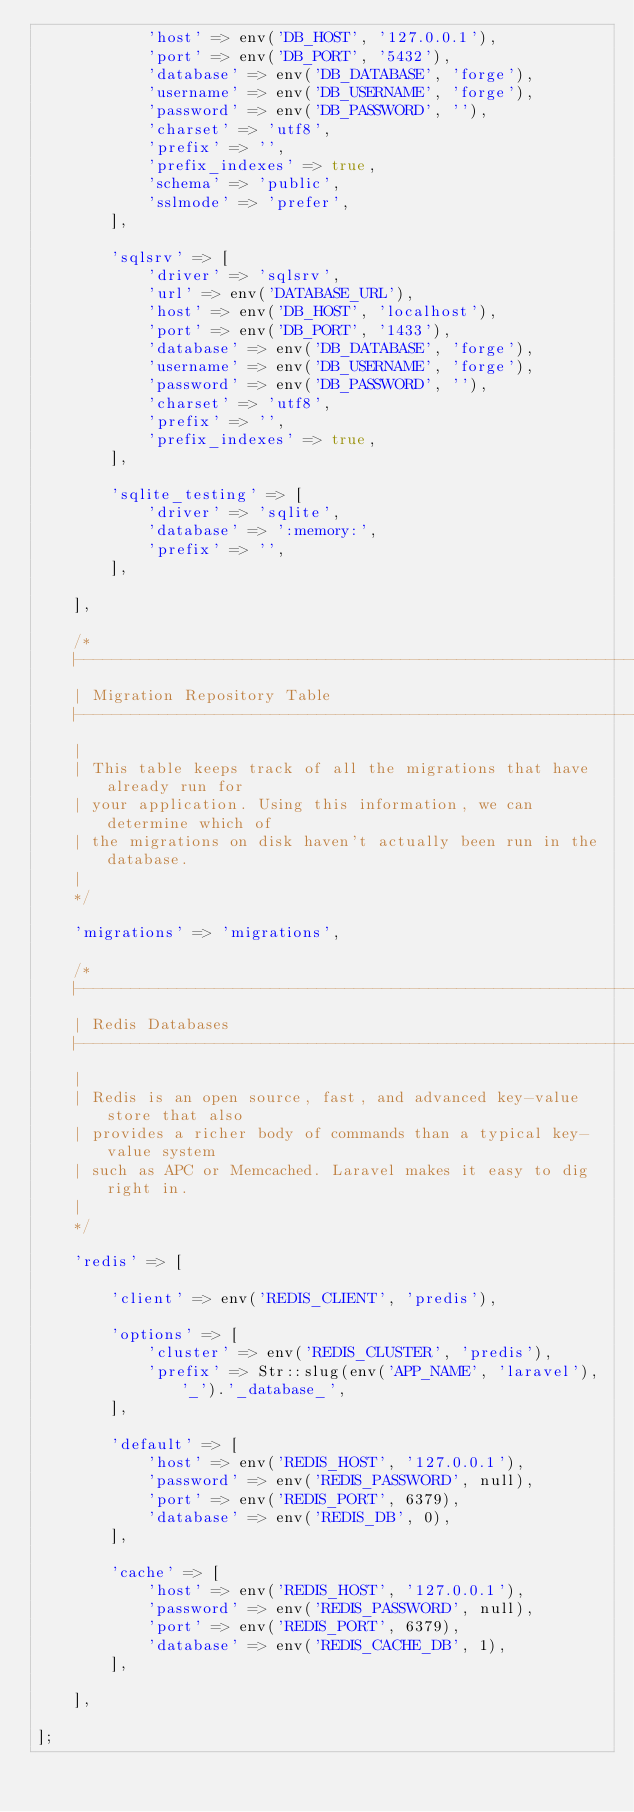Convert code to text. <code><loc_0><loc_0><loc_500><loc_500><_PHP_>            'host' => env('DB_HOST', '127.0.0.1'),
            'port' => env('DB_PORT', '5432'),
            'database' => env('DB_DATABASE', 'forge'),
            'username' => env('DB_USERNAME', 'forge'),
            'password' => env('DB_PASSWORD', ''),
            'charset' => 'utf8',
            'prefix' => '',
            'prefix_indexes' => true,
            'schema' => 'public',
            'sslmode' => 'prefer',
        ],

        'sqlsrv' => [
            'driver' => 'sqlsrv',
            'url' => env('DATABASE_URL'),
            'host' => env('DB_HOST', 'localhost'),
            'port' => env('DB_PORT', '1433'),
            'database' => env('DB_DATABASE', 'forge'),
            'username' => env('DB_USERNAME', 'forge'),
            'password' => env('DB_PASSWORD', ''),
            'charset' => 'utf8',
            'prefix' => '',
            'prefix_indexes' => true,
        ],

        'sqlite_testing' => [
            'driver' => 'sqlite',
            'database' => ':memory:',
            'prefix' => '',
        ],

    ],

    /*
    |--------------------------------------------------------------------------
    | Migration Repository Table
    |--------------------------------------------------------------------------
    |
    | This table keeps track of all the migrations that have already run for
    | your application. Using this information, we can determine which of
    | the migrations on disk haven't actually been run in the database.
    |
    */

    'migrations' => 'migrations',

    /*
    |--------------------------------------------------------------------------
    | Redis Databases
    |--------------------------------------------------------------------------
    |
    | Redis is an open source, fast, and advanced key-value store that also
    | provides a richer body of commands than a typical key-value system
    | such as APC or Memcached. Laravel makes it easy to dig right in.
    |
    */

    'redis' => [

        'client' => env('REDIS_CLIENT', 'predis'),

        'options' => [
            'cluster' => env('REDIS_CLUSTER', 'predis'),
            'prefix' => Str::slug(env('APP_NAME', 'laravel'), '_').'_database_',
        ],

        'default' => [
            'host' => env('REDIS_HOST', '127.0.0.1'),
            'password' => env('REDIS_PASSWORD', null),
            'port' => env('REDIS_PORT', 6379),
            'database' => env('REDIS_DB', 0),
        ],

        'cache' => [
            'host' => env('REDIS_HOST', '127.0.0.1'),
            'password' => env('REDIS_PASSWORD', null),
            'port' => env('REDIS_PORT', 6379),
            'database' => env('REDIS_CACHE_DB', 1),
        ],

    ],

];
</code> 